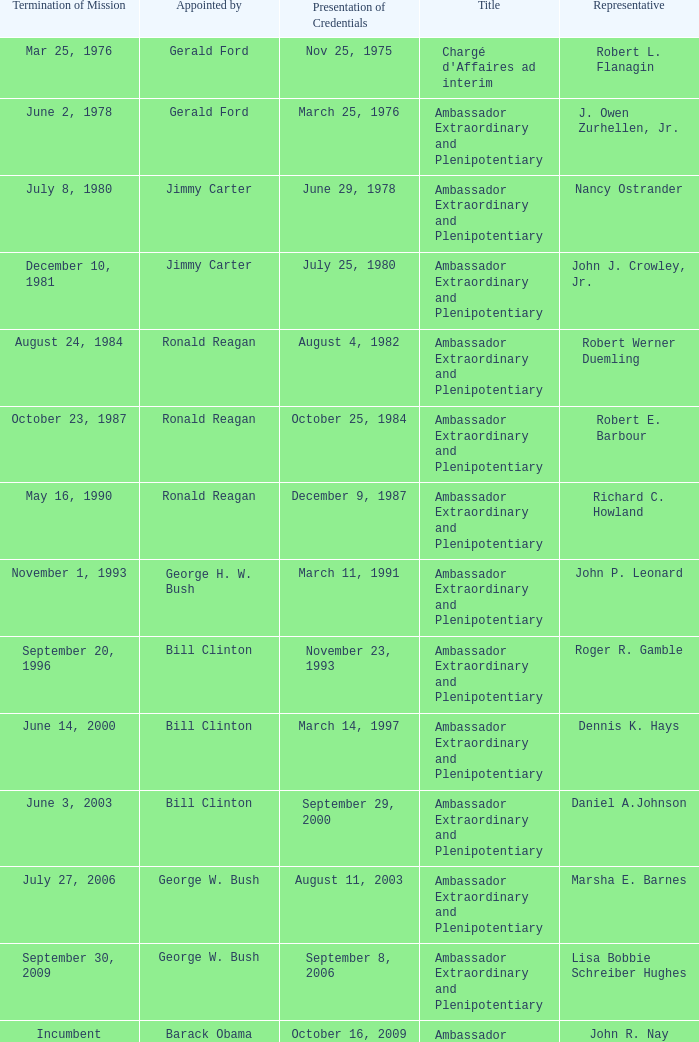Which representative was the Ambassador Extraordinary and Plenipotentiary and had a Termination of Mission date September 20, 1996? Roger R. Gamble. 